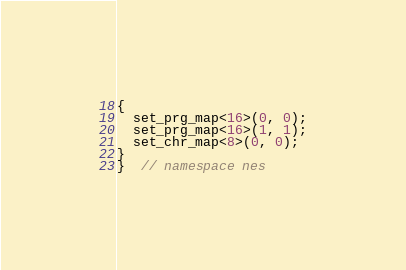<code> <loc_0><loc_0><loc_500><loc_500><_C++_>{
  set_prg_map<16>(0, 0);
  set_prg_map<16>(1, 1);
  set_chr_map<8>(0, 0);
}
}  // namespace nes
</code> 